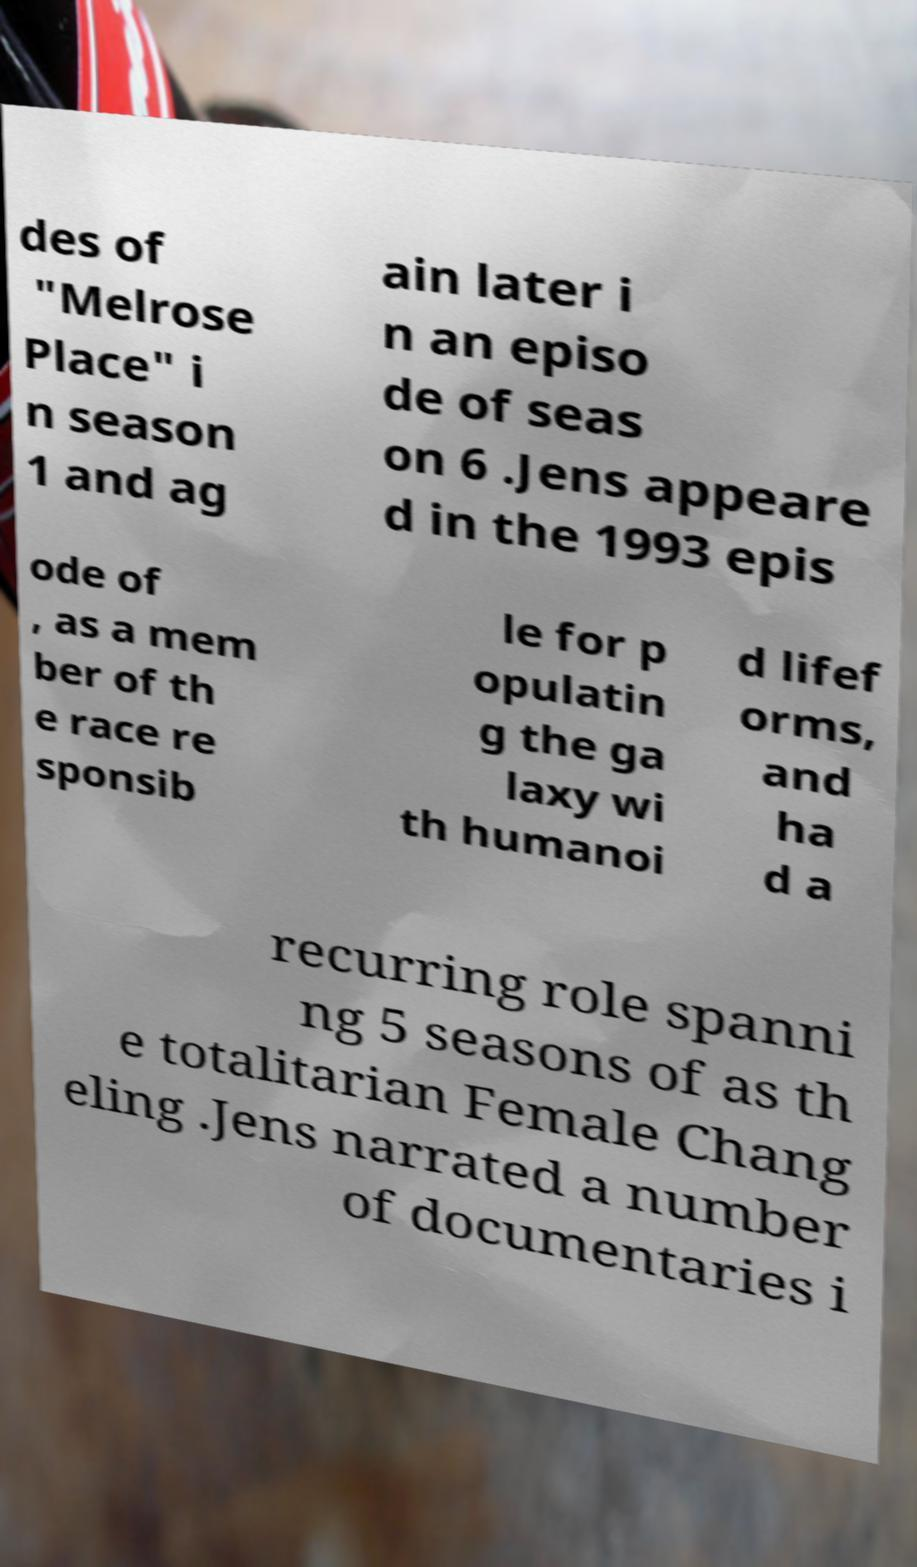Could you assist in decoding the text presented in this image and type it out clearly? des of "Melrose Place" i n season 1 and ag ain later i n an episo de of seas on 6 .Jens appeare d in the 1993 epis ode of , as a mem ber of th e race re sponsib le for p opulatin g the ga laxy wi th humanoi d lifef orms, and ha d a recurring role spanni ng 5 seasons of as th e totalitarian Female Chang eling .Jens narrated a number of documentaries i 